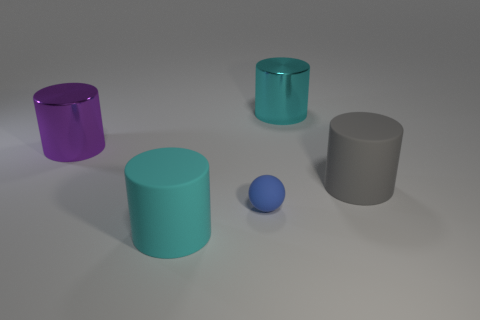How many cyan cylinders must be subtracted to get 1 cyan cylinders? 1 Subtract all purple metallic cylinders. How many cylinders are left? 3 Add 2 matte balls. How many objects exist? 7 Subtract all balls. How many objects are left? 4 Subtract all purple cylinders. How many cylinders are left? 3 Subtract all small metallic cylinders. Subtract all big gray matte cylinders. How many objects are left? 4 Add 3 small rubber spheres. How many small rubber spheres are left? 4 Add 3 small green rubber things. How many small green rubber things exist? 3 Subtract 0 yellow blocks. How many objects are left? 5 Subtract 2 cylinders. How many cylinders are left? 2 